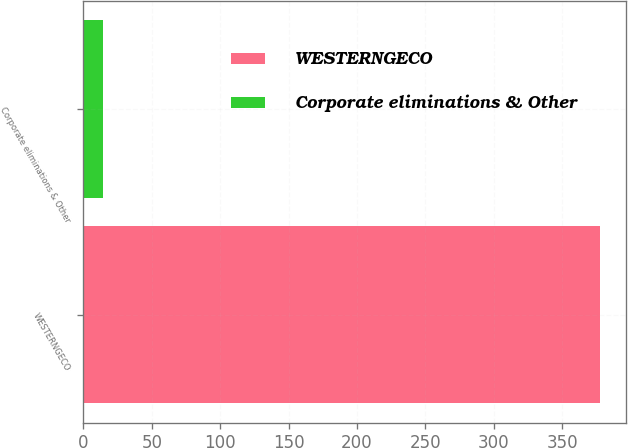<chart> <loc_0><loc_0><loc_500><loc_500><bar_chart><fcel>WESTERNGECO<fcel>Corporate eliminations & Other<nl><fcel>378<fcel>14<nl></chart> 